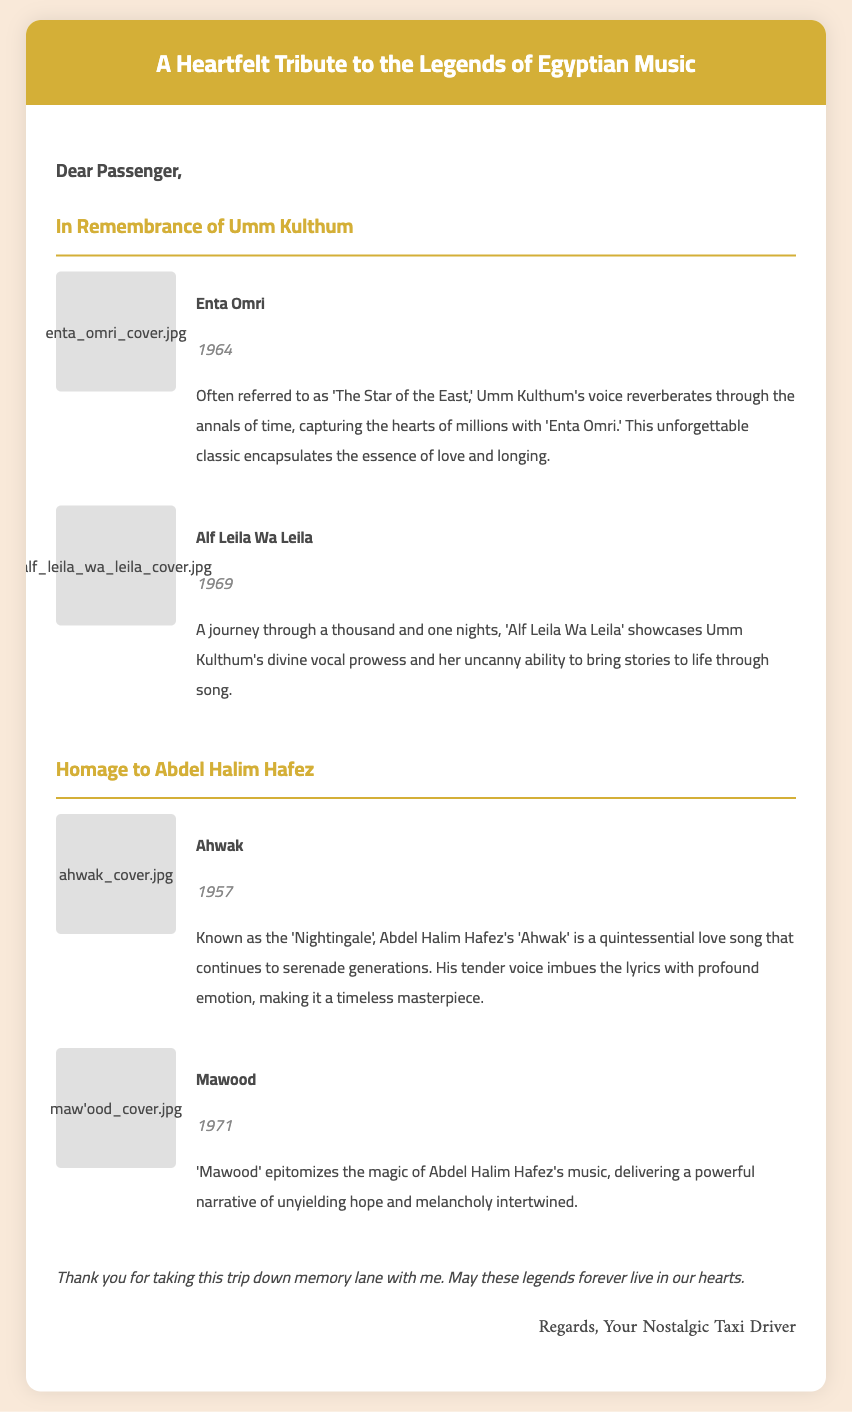What is the title of the card? The title of the card is mentioned in the header at the top of the document.
Answer: A Heartfelt Tribute to the Legends of Egyptian Music Who is referred to as 'The Star of the East'? This title is associated with Umm Kulthum in the description provided in the document.
Answer: Umm Kulthum What year was 'Enta Omri' released? The year is stated in the information section under Umm Kulthum's album.
Answer: 1964 What is the nickname of Abdel Halim Hafez? The document mentions his nickname in connection with his album 'Ahwak'.
Answer: Nightingale How many albums are featured for Umm Kulthum? The document lists the albums in a section dedicated to Umm Kulthum.
Answer: 2 What is the main theme of 'Mawood'? The document describes the themes conveyed through the album's narrative.
Answer: Hope and melancholy What color is used for the card's header? The document uses specific colors to define sections, with the header having a distinct color.
Answer: Gold Which album is associated with a love song? The description specifies that the album 'Ahwak' is a quintessential love song.
Answer: Ahwak Who is the sign-off from? The closing section provides the identity of the person expressing gratitude at the end of the card.
Answer: Your Nostalgic Taxi Driver 